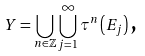<formula> <loc_0><loc_0><loc_500><loc_500>Y = \bigcup _ { n \in \mathbb { Z } } \bigcup _ { j = 1 } ^ { \infty } \tau ^ { n } \left ( E _ { j } \right ) \text {,}</formula> 